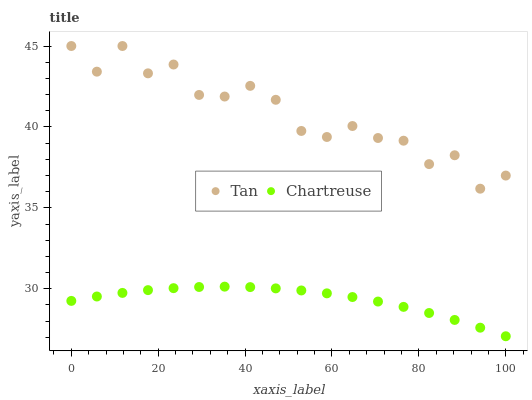Does Chartreuse have the minimum area under the curve?
Answer yes or no. Yes. Does Tan have the maximum area under the curve?
Answer yes or no. Yes. Does Chartreuse have the maximum area under the curve?
Answer yes or no. No. Is Chartreuse the smoothest?
Answer yes or no. Yes. Is Tan the roughest?
Answer yes or no. Yes. Is Chartreuse the roughest?
Answer yes or no. No. Does Chartreuse have the lowest value?
Answer yes or no. Yes. Does Tan have the highest value?
Answer yes or no. Yes. Does Chartreuse have the highest value?
Answer yes or no. No. Is Chartreuse less than Tan?
Answer yes or no. Yes. Is Tan greater than Chartreuse?
Answer yes or no. Yes. Does Chartreuse intersect Tan?
Answer yes or no. No. 